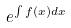<formula> <loc_0><loc_0><loc_500><loc_500>e ^ { \int f ( x ) d x }</formula> 